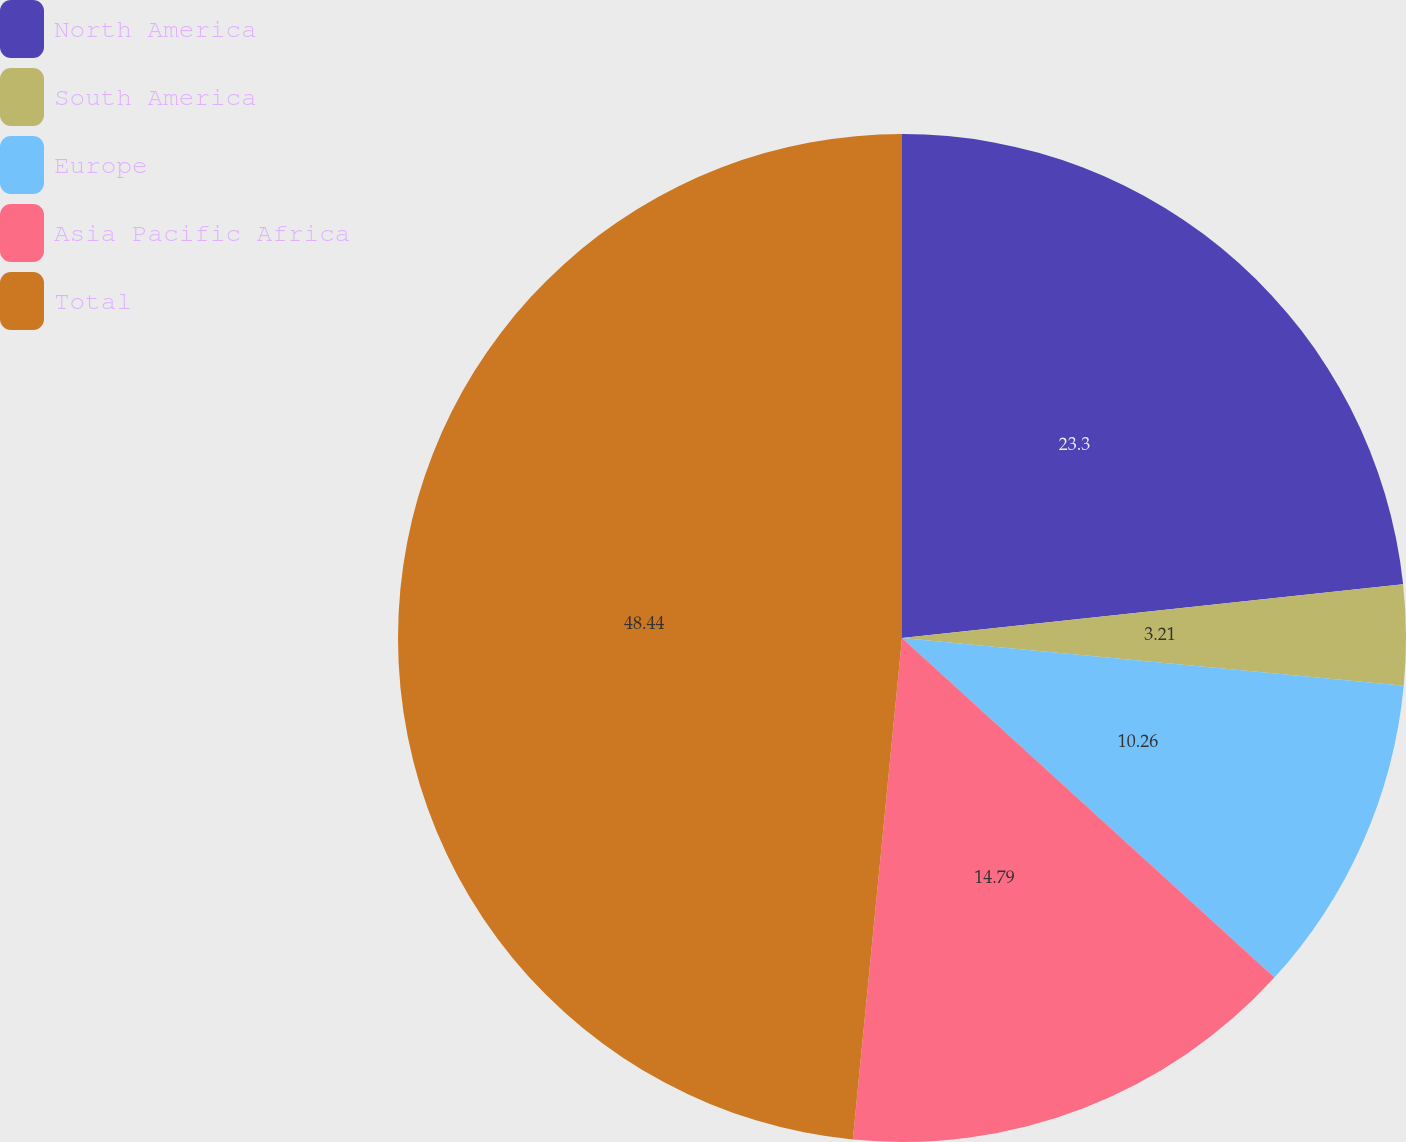<chart> <loc_0><loc_0><loc_500><loc_500><pie_chart><fcel>North America<fcel>South America<fcel>Europe<fcel>Asia Pacific Africa<fcel>Total<nl><fcel>23.3%<fcel>3.21%<fcel>10.26%<fcel>14.79%<fcel>48.45%<nl></chart> 